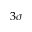Convert formula to latex. <formula><loc_0><loc_0><loc_500><loc_500>3 \sigma</formula> 